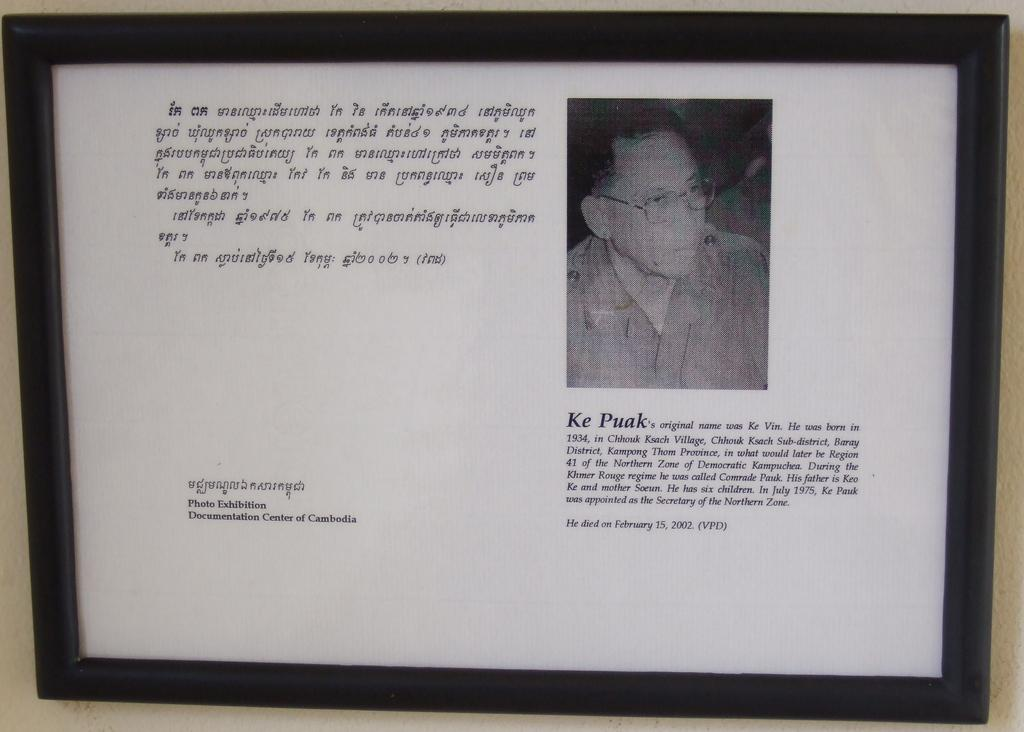<image>
Share a concise interpretation of the image provided. Ke Puak is framed in a black frame with some text at a photo exibition. 